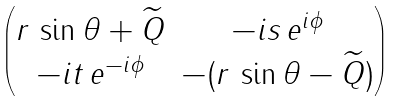Convert formula to latex. <formula><loc_0><loc_0><loc_500><loc_500>\begin{pmatrix} r \, \sin \theta + \widetilde { Q } & - i s \, e ^ { i \phi } \\ - i t \, e ^ { - i \phi } & - ( r \, \sin \theta - \widetilde { Q } ) \end{pmatrix}</formula> 